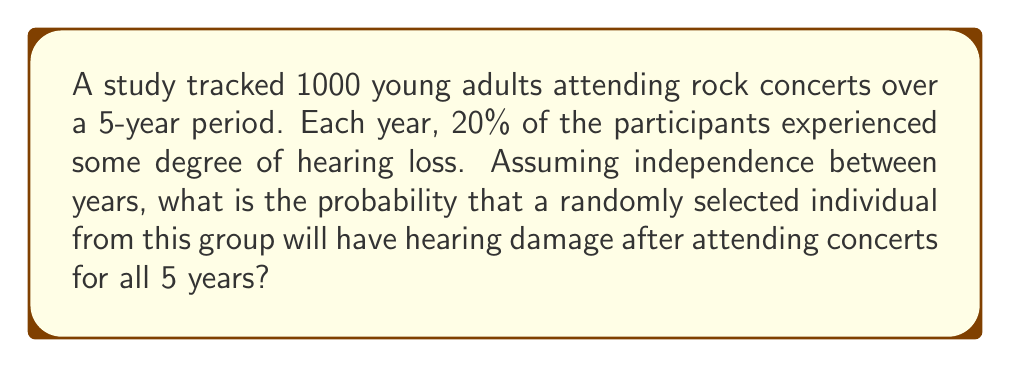Can you answer this question? Let's approach this step-by-step:

1) First, we need to understand what the question is asking. We're looking for the probability of hearing damage occurring at least once over the 5-year period.

2) It's easier to calculate the probability of the opposite event - not experiencing hearing damage in any of the 5 years - and then subtract this from 1.

3) The probability of not experiencing hearing damage in one year is:
   $1 - 0.20 = 0.80$ or $80\%$

4) Assuming independence between years, we can use the multiplication rule of probability. The probability of not experiencing hearing damage for all 5 years is:
   $$(0.80)^5 = 0.32768$$

5) Therefore, the probability of experiencing hearing damage at least once in the 5 years is:
   $$1 - (0.80)^5 = 1 - 0.32768 = 0.67232$$

6) Convert to a percentage:
   $$0.67232 \times 100\% = 67.232\%$$

This means there's approximately a 67.2% chance that a randomly selected individual will experience some degree of hearing damage over the 5-year period of frequent concert attendance.
Answer: $67.2\%$ 